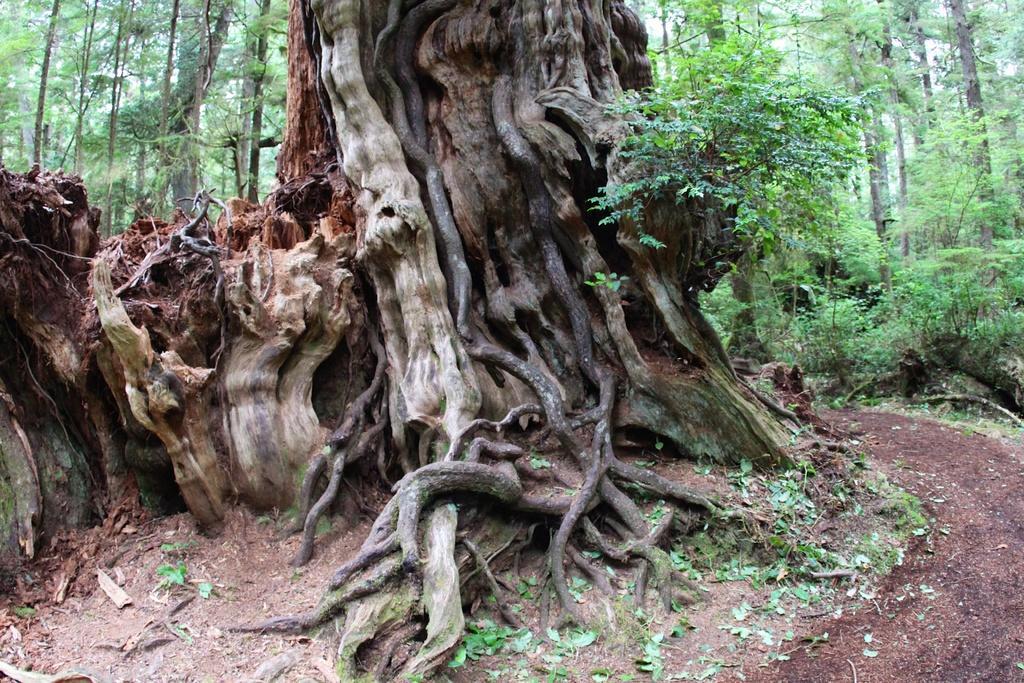Could you give a brief overview of what you see in this image? In the image in the center,we can see trees,grass and plants. 